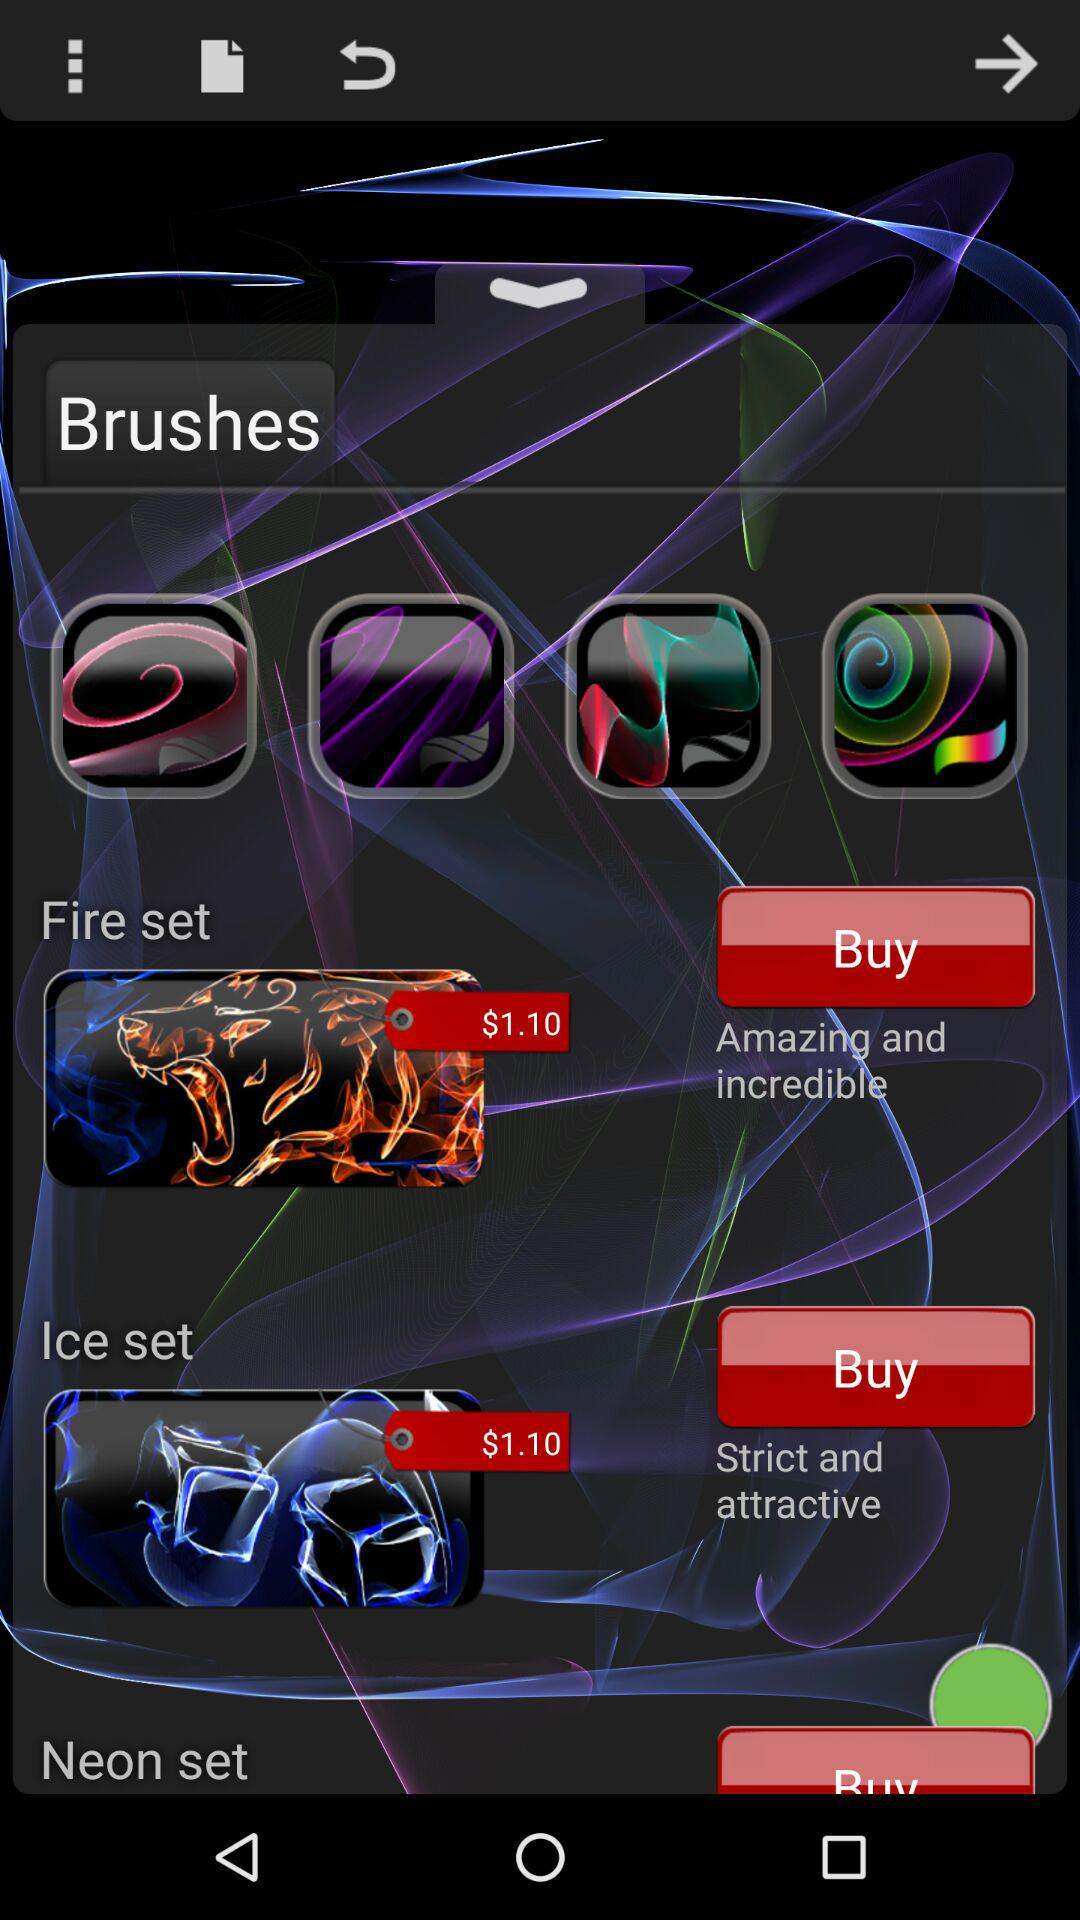What is the buying price of fire set brushes? The buying price of fire set brushes is $1.10. 